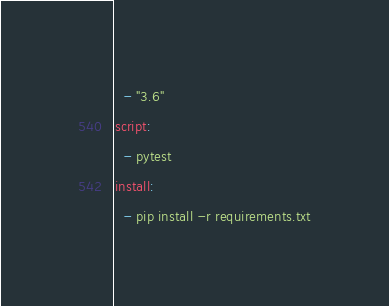<code> <loc_0><loc_0><loc_500><loc_500><_YAML_>  - "3.6"
script:
  - pytest
install:
  - pip install -r requirements.txt
</code> 